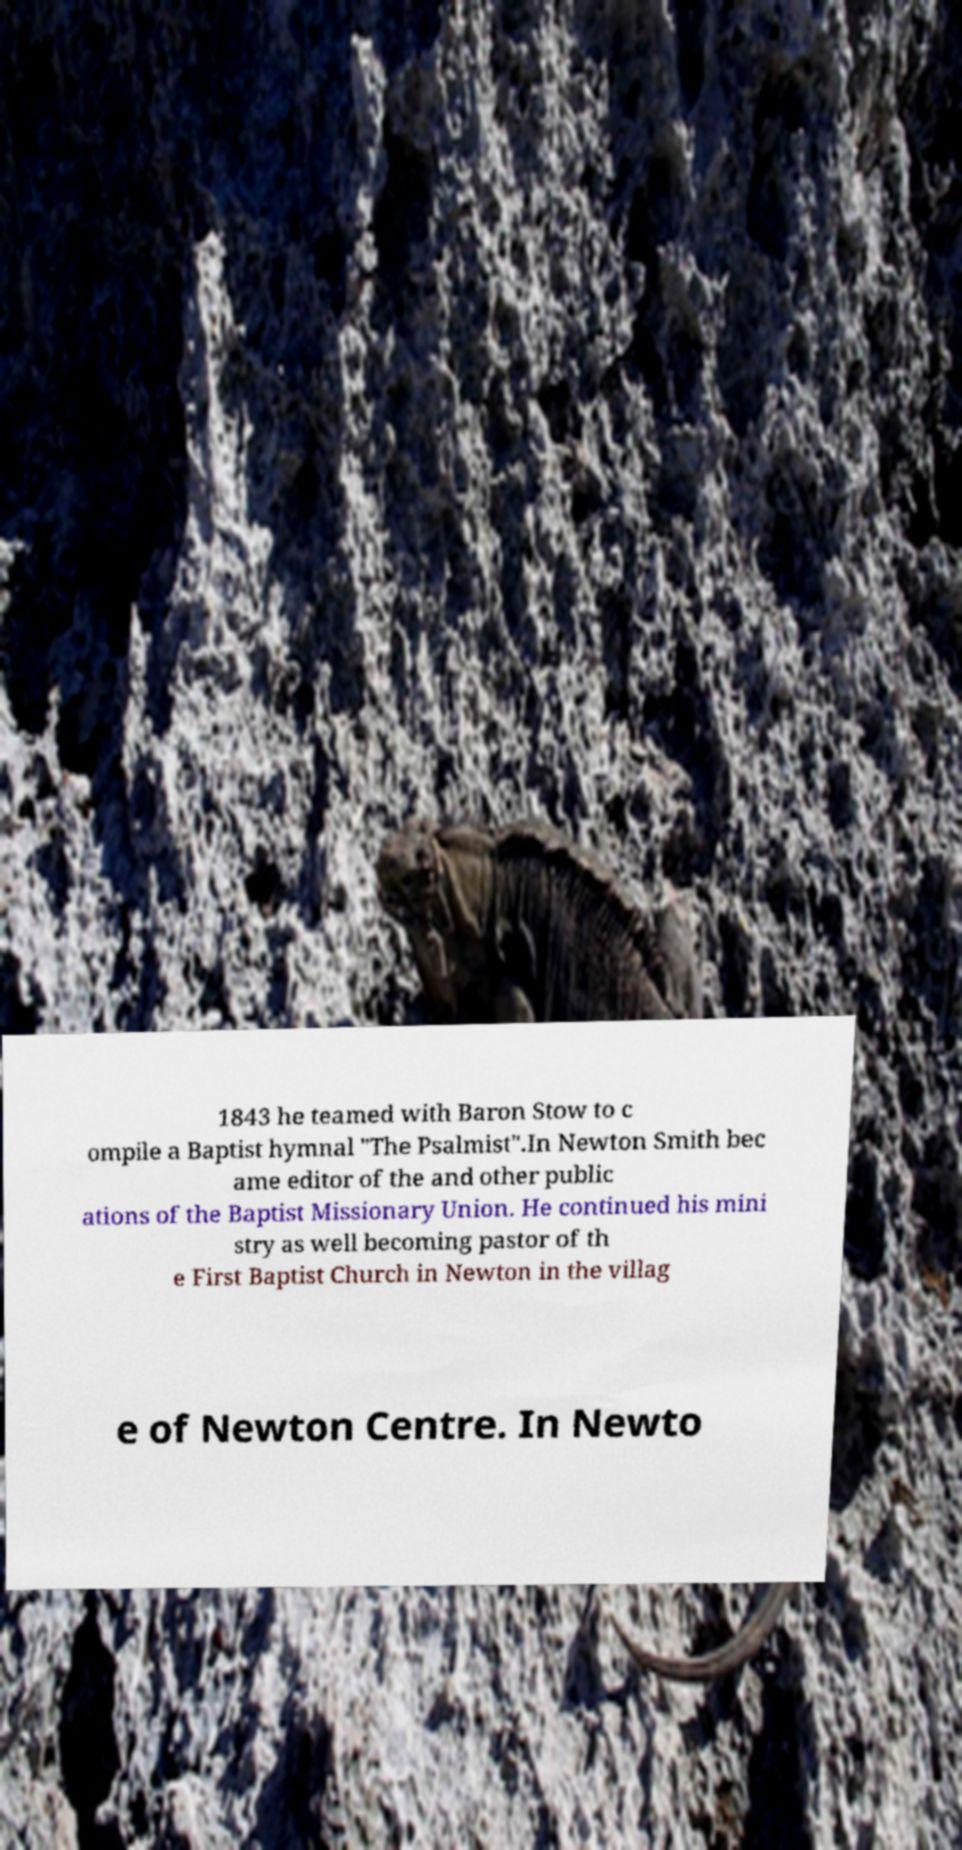Can you read and provide the text displayed in the image?This photo seems to have some interesting text. Can you extract and type it out for me? 1843 he teamed with Baron Stow to c ompile a Baptist hymnal "The Psalmist".In Newton Smith bec ame editor of the and other public ations of the Baptist Missionary Union. He continued his mini stry as well becoming pastor of th e First Baptist Church in Newton in the villag e of Newton Centre. In Newto 